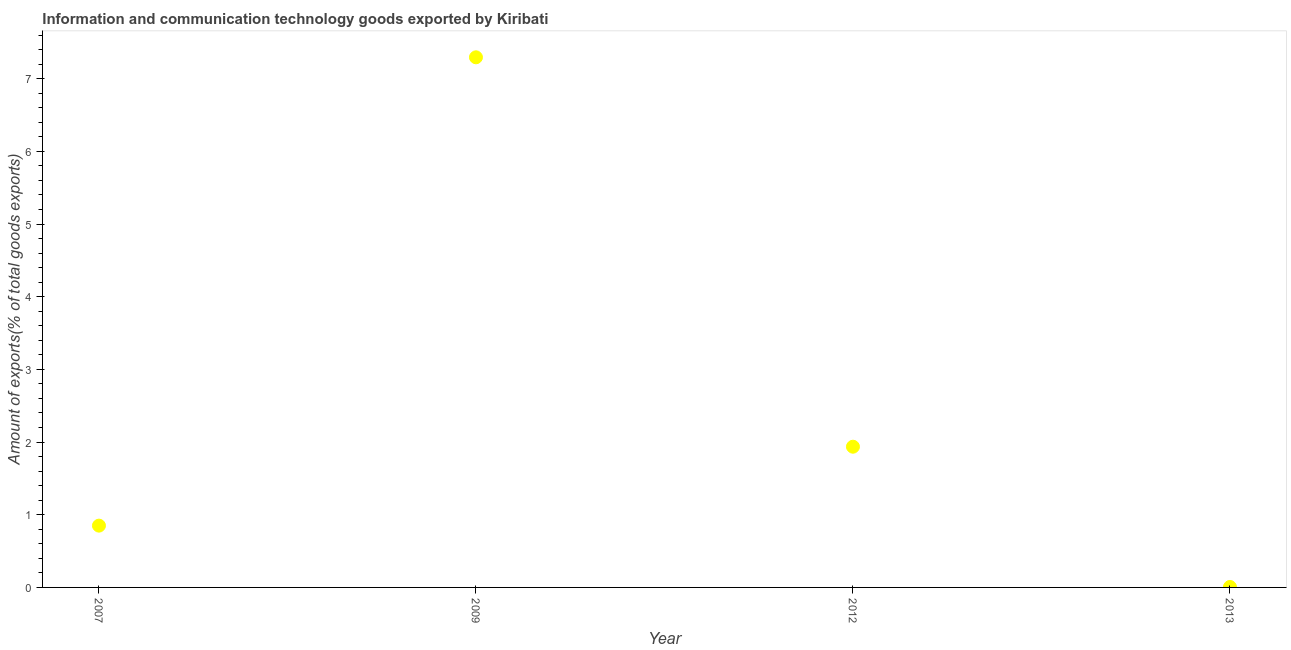What is the amount of ict goods exports in 2013?
Offer a very short reply. 0.01. Across all years, what is the maximum amount of ict goods exports?
Offer a terse response. 7.29. Across all years, what is the minimum amount of ict goods exports?
Offer a terse response. 0.01. What is the sum of the amount of ict goods exports?
Give a very brief answer. 10.09. What is the difference between the amount of ict goods exports in 2012 and 2013?
Give a very brief answer. 1.93. What is the average amount of ict goods exports per year?
Keep it short and to the point. 2.52. What is the median amount of ict goods exports?
Offer a very short reply. 1.39. In how many years, is the amount of ict goods exports greater than 4.8 %?
Offer a very short reply. 1. What is the ratio of the amount of ict goods exports in 2009 to that in 2013?
Offer a very short reply. 1161.96. Is the amount of ict goods exports in 2007 less than that in 2013?
Offer a very short reply. No. What is the difference between the highest and the second highest amount of ict goods exports?
Offer a terse response. 5.36. What is the difference between the highest and the lowest amount of ict goods exports?
Make the answer very short. 7.29. Does the amount of ict goods exports monotonically increase over the years?
Your answer should be compact. No. How many years are there in the graph?
Your response must be concise. 4. What is the difference between two consecutive major ticks on the Y-axis?
Provide a short and direct response. 1. Does the graph contain grids?
Give a very brief answer. No. What is the title of the graph?
Offer a terse response. Information and communication technology goods exported by Kiribati. What is the label or title of the X-axis?
Ensure brevity in your answer.  Year. What is the label or title of the Y-axis?
Provide a short and direct response. Amount of exports(% of total goods exports). What is the Amount of exports(% of total goods exports) in 2007?
Your response must be concise. 0.85. What is the Amount of exports(% of total goods exports) in 2009?
Keep it short and to the point. 7.29. What is the Amount of exports(% of total goods exports) in 2012?
Provide a short and direct response. 1.94. What is the Amount of exports(% of total goods exports) in 2013?
Offer a terse response. 0.01. What is the difference between the Amount of exports(% of total goods exports) in 2007 and 2009?
Provide a succinct answer. -6.44. What is the difference between the Amount of exports(% of total goods exports) in 2007 and 2012?
Offer a very short reply. -1.09. What is the difference between the Amount of exports(% of total goods exports) in 2007 and 2013?
Offer a very short reply. 0.84. What is the difference between the Amount of exports(% of total goods exports) in 2009 and 2012?
Ensure brevity in your answer.  5.36. What is the difference between the Amount of exports(% of total goods exports) in 2009 and 2013?
Ensure brevity in your answer.  7.29. What is the difference between the Amount of exports(% of total goods exports) in 2012 and 2013?
Provide a succinct answer. 1.93. What is the ratio of the Amount of exports(% of total goods exports) in 2007 to that in 2009?
Your answer should be compact. 0.12. What is the ratio of the Amount of exports(% of total goods exports) in 2007 to that in 2012?
Your answer should be compact. 0.44. What is the ratio of the Amount of exports(% of total goods exports) in 2007 to that in 2013?
Provide a succinct answer. 135.44. What is the ratio of the Amount of exports(% of total goods exports) in 2009 to that in 2012?
Your answer should be very brief. 3.77. What is the ratio of the Amount of exports(% of total goods exports) in 2009 to that in 2013?
Offer a very short reply. 1161.95. What is the ratio of the Amount of exports(% of total goods exports) in 2012 to that in 2013?
Provide a short and direct response. 308.45. 